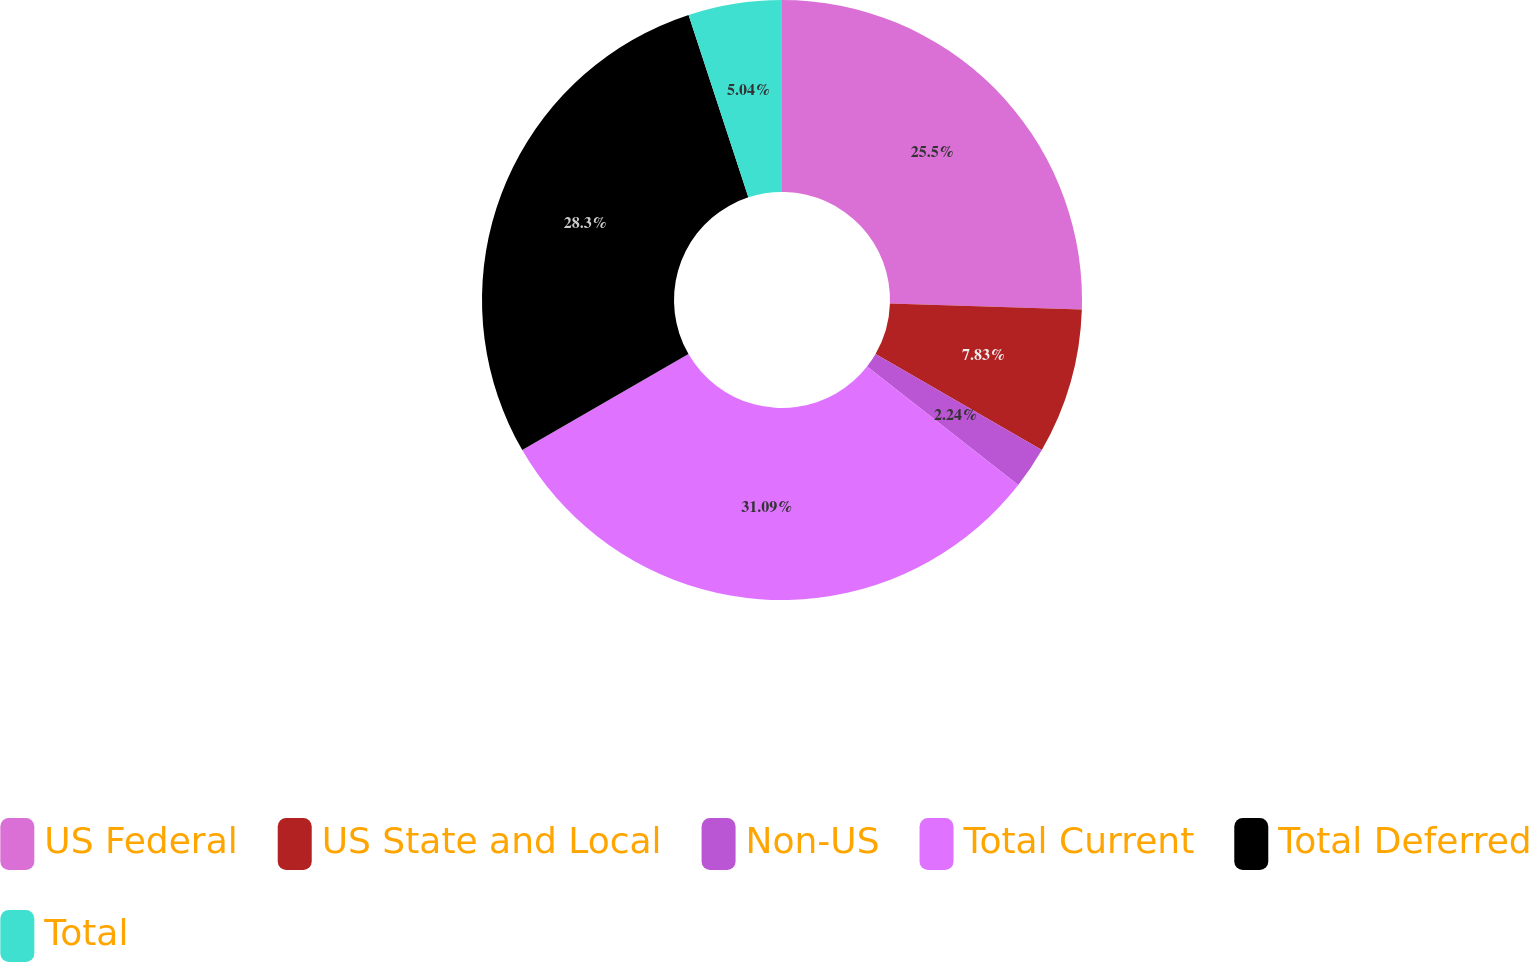<chart> <loc_0><loc_0><loc_500><loc_500><pie_chart><fcel>US Federal<fcel>US State and Local<fcel>Non-US<fcel>Total Current<fcel>Total Deferred<fcel>Total<nl><fcel>25.5%<fcel>7.83%<fcel>2.24%<fcel>31.09%<fcel>28.3%<fcel>5.04%<nl></chart> 